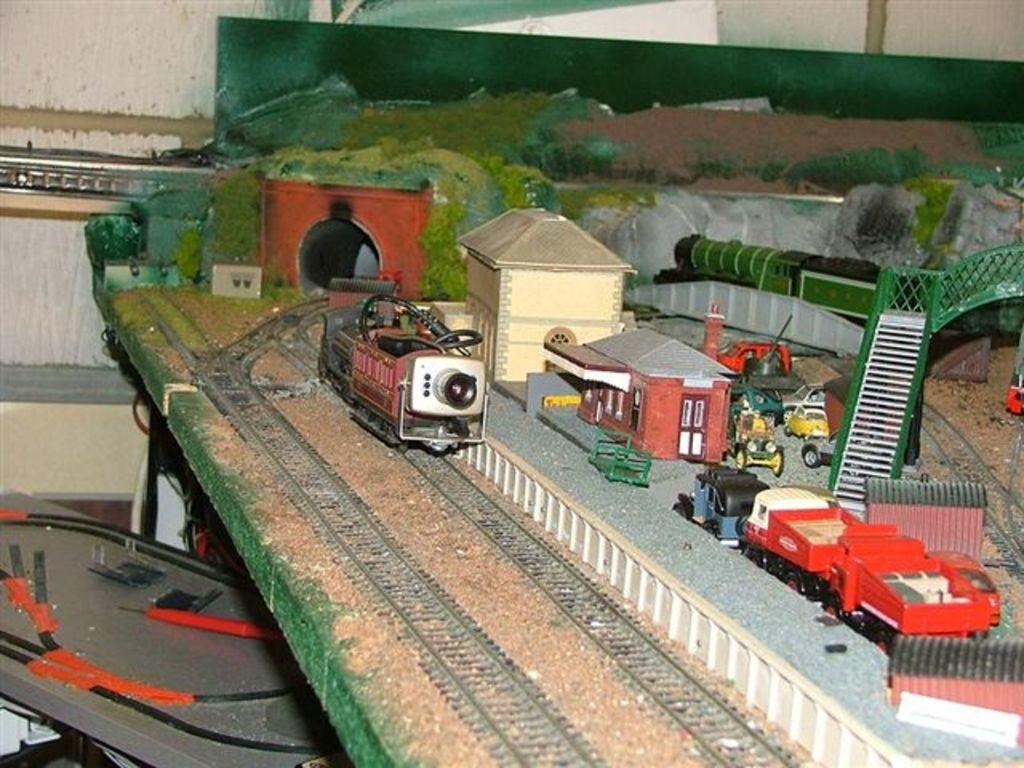What is the main subject of the picture? The main subject of the picture is a miniature set. What type of tracks are present in the miniature set? The miniature set contains tracks. What is moving on the tracks? There are trains on the tracks. How many buildings are in the miniature set? There are 2 buildings in the miniature set. Are there any structures in the miniature set that allow trains to pass through or over obstacles? Yes, there is a tunnel and a bridge in the miniature set. What other types of vehicles are present in the miniature set? There are vehicles in the miniature set. Can you tell me how many yaks are grazing in the room next to the miniature set in the image? There is no room or yaks present in the image; it features a miniature set with trains, tracks, buildings, and vehicles. 